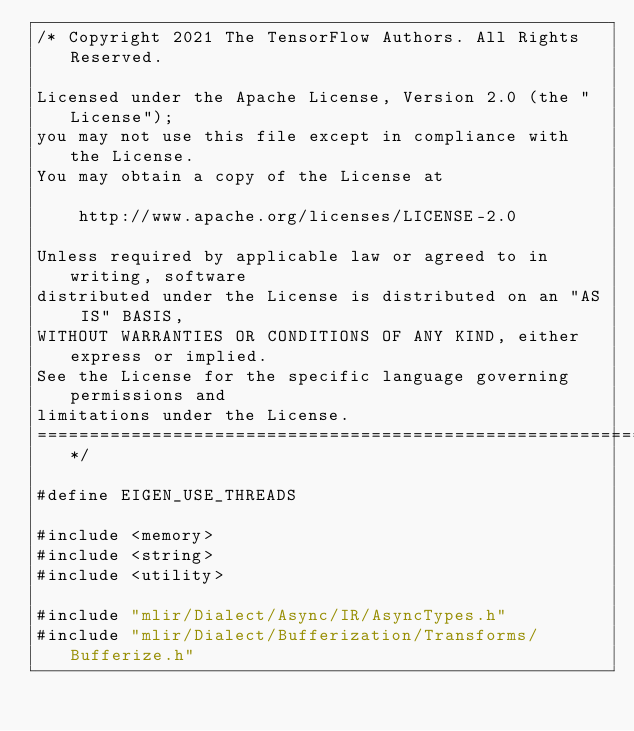<code> <loc_0><loc_0><loc_500><loc_500><_C++_>/* Copyright 2021 The TensorFlow Authors. All Rights Reserved.

Licensed under the Apache License, Version 2.0 (the "License");
you may not use this file except in compliance with the License.
You may obtain a copy of the License at

    http://www.apache.org/licenses/LICENSE-2.0

Unless required by applicable law or agreed to in writing, software
distributed under the License is distributed on an "AS IS" BASIS,
WITHOUT WARRANTIES OR CONDITIONS OF ANY KIND, either express or implied.
See the License for the specific language governing permissions and
limitations under the License.
==============================================================================*/

#define EIGEN_USE_THREADS

#include <memory>
#include <string>
#include <utility>

#include "mlir/Dialect/Async/IR/AsyncTypes.h"
#include "mlir/Dialect/Bufferization/Transforms/Bufferize.h"</code> 